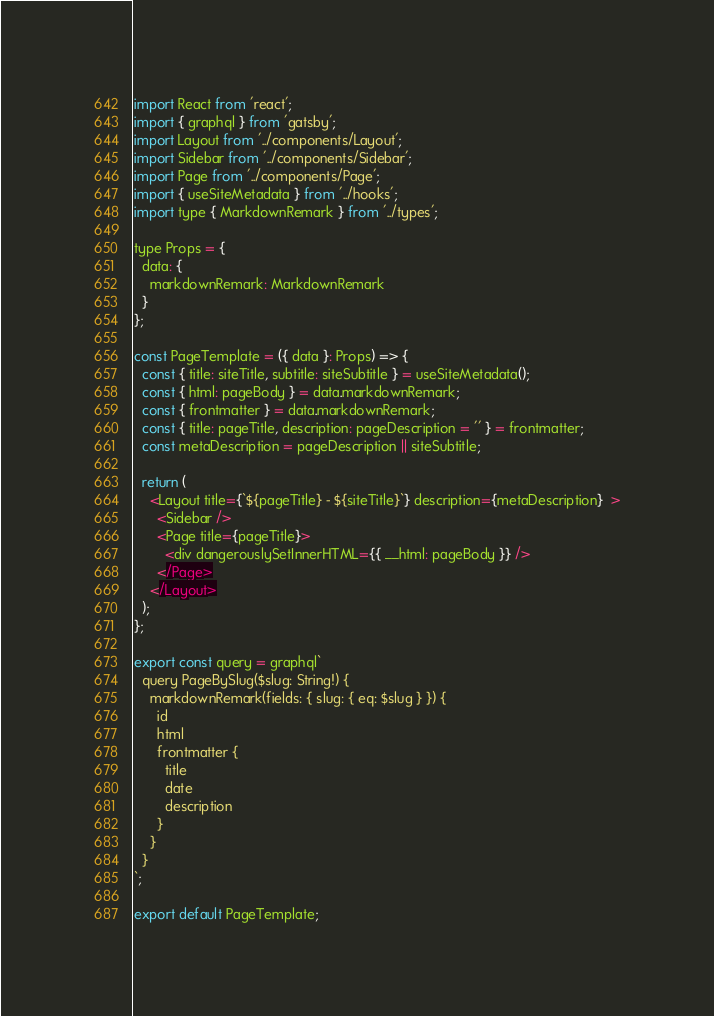<code> <loc_0><loc_0><loc_500><loc_500><_JavaScript_>import React from 'react';
import { graphql } from 'gatsby';
import Layout from '../components/Layout';
import Sidebar from '../components/Sidebar';
import Page from '../components/Page';
import { useSiteMetadata } from '../hooks';
import type { MarkdownRemark } from '../types';

type Props = {
  data: {
    markdownRemark: MarkdownRemark
  }
};

const PageTemplate = ({ data }: Props) => {
  const { title: siteTitle, subtitle: siteSubtitle } = useSiteMetadata();
  const { html: pageBody } = data.markdownRemark;
  const { frontmatter } = data.markdownRemark;
  const { title: pageTitle, description: pageDescription = '' } = frontmatter;
  const metaDescription = pageDescription || siteSubtitle; 

  return (
    <Layout title={`${pageTitle} - ${siteTitle}`} description={metaDescription}  >
      <Sidebar />
      <Page title={pageTitle}>
        <div dangerouslySetInnerHTML={{ __html: pageBody }} />
      </Page>
    </Layout>
  );
};

export const query = graphql`
  query PageBySlug($slug: String!) {
    markdownRemark(fields: { slug: { eq: $slug } }) {
      id
      html
      frontmatter {
        title
        date
        description 
      }
    }
  }
`;

export default PageTemplate;
</code> 